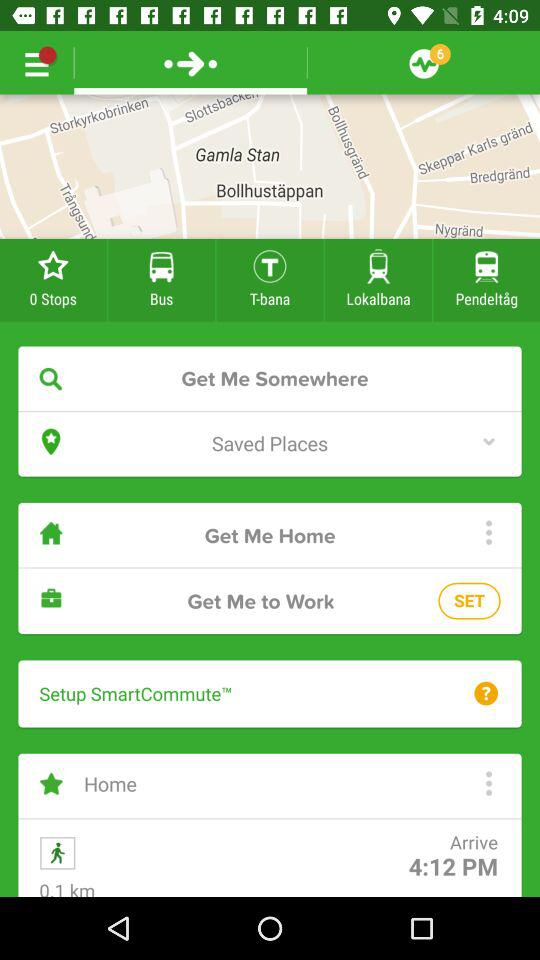What is the arrival time? The arrival time is 4:12 PM. 